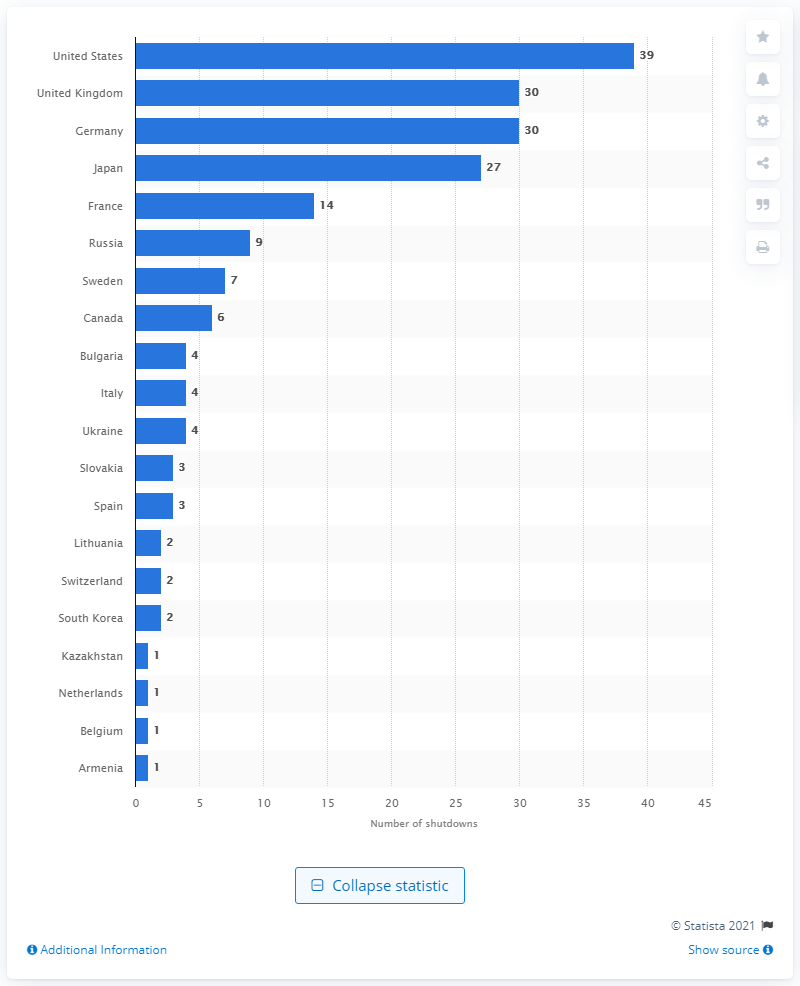Mention a couple of crucial points in this snapshot. In April 2021, a total of 39 nuclear reactors were permanently shut down in the United States. 